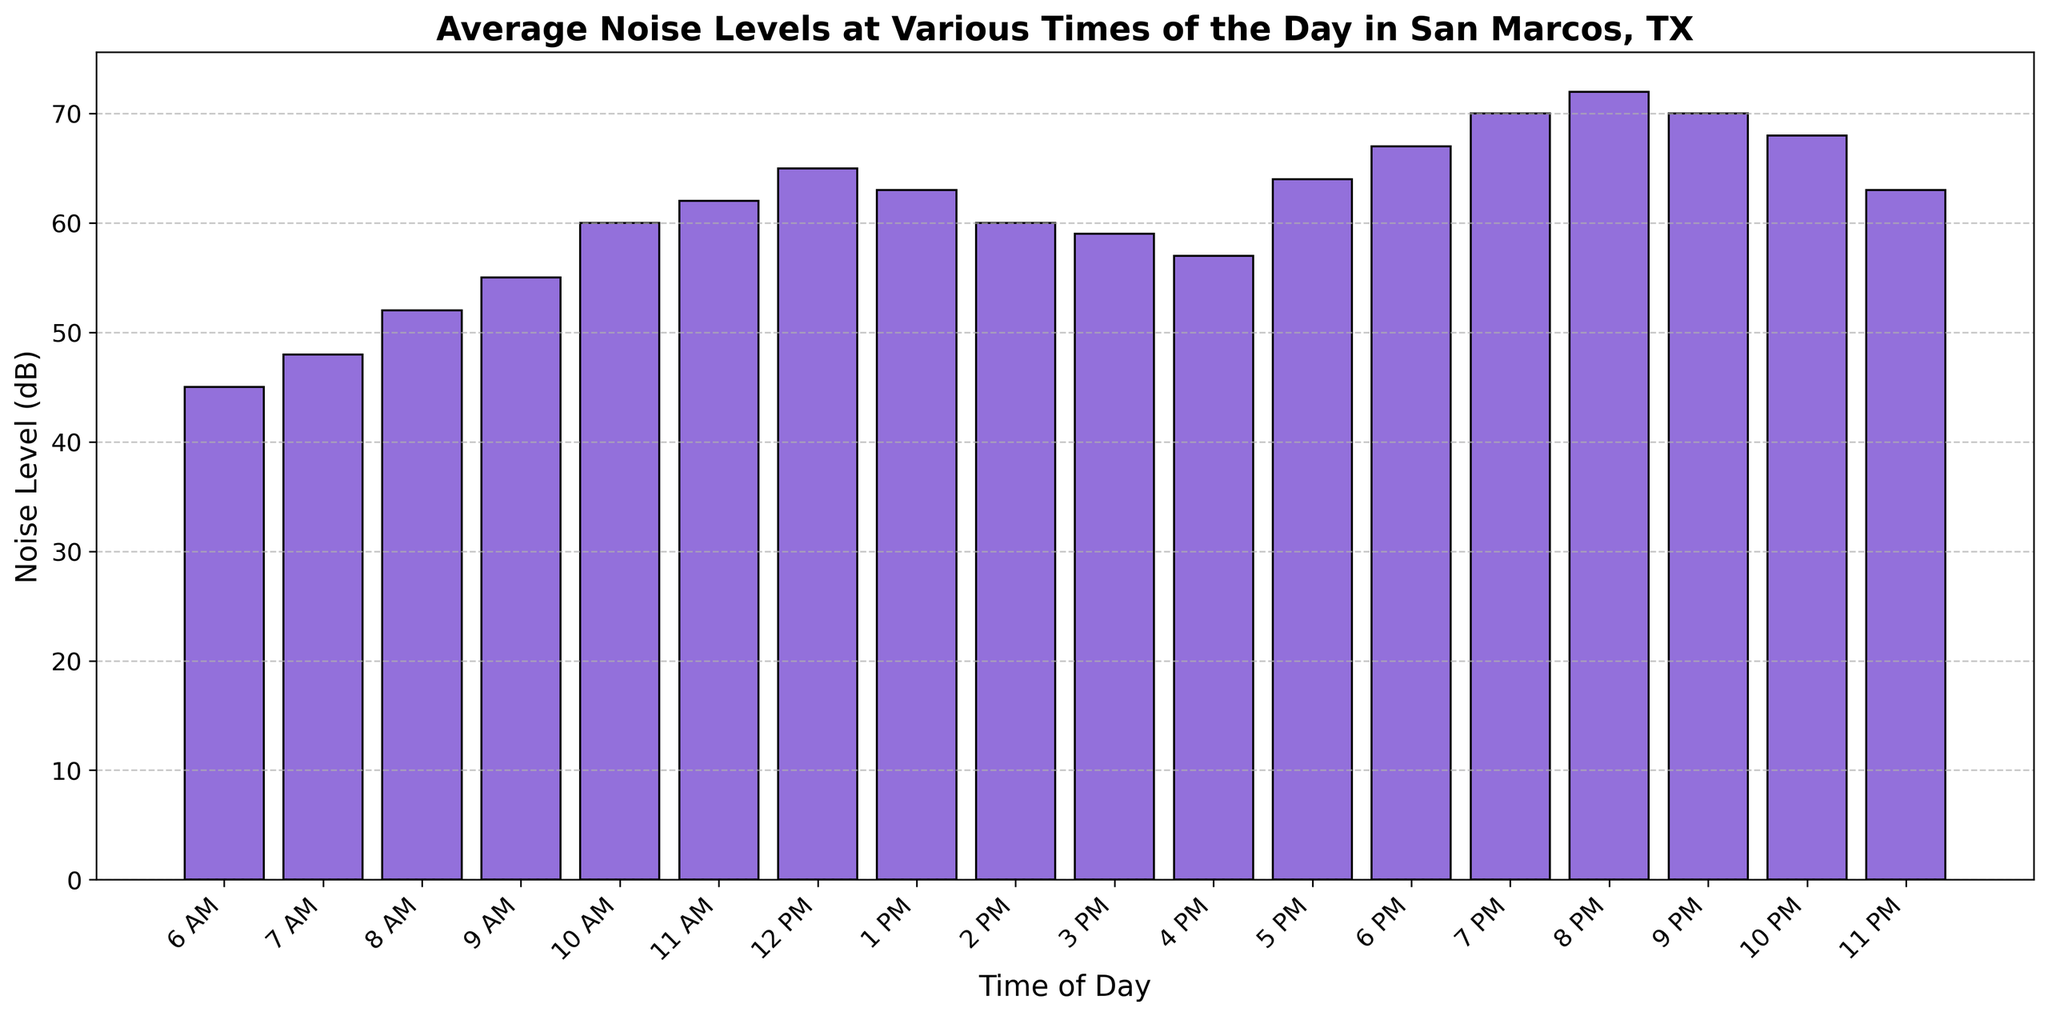What's the peak noise level throughout the day? First, scan the bar heights, noting the tallest bar. The highest bar corresponds to 8 PM with a noise level of 72 dB.
Answer: 72 dB During which time slots is the noise level equal to 70 dB? Check the heights of the bars and find those equal to the level at which 70 dB is marked. The bars at 7 PM and 9 PM represent 70 dB.
Answer: 7 PM, 9 PM When does the noise level first exceed 60 dB? Find the first instance where the bar height surpasses the 60 dB line on the y-axis. This occurs at 10 AM.
Answer: 10 AM What is the difference in noise level between 8 AM and 5 PM? Locate the bars for 8 AM (52 dB) and 5 PM (64 dB), then subtract the lower value from the higher value: 64 dB - 52 dB = 12 dB.
Answer: 12 dB What times have noise levels below 50 dB? Identify bars lower than the 50 dB mark. These correspond to 6 AM and 7 AM.
Answer: 6 AM, 7 AM Is the noise level at 6 PM greater than at 2 PM? Compare the heights of the bars labeled 6 PM (67 dB) and 2 PM (60 dB); 67 dB is greater than 60 dB.
Answer: Yes What’s the average noise level between 10 PM and 11 PM? Find noise levels for 10 PM (68 dB) and 11 PM (63 dB), sum them (68 + 63 = 131), then divide by 2. The average is 131 / 2 = 65.5 dB.
Answer: 65.5 dB At what time(s) is the noise level exactly 63 dB? Check bar heights to see which correspond exactly to 63 dB. These occur at 1 PM and 11 PM.
Answer: 1 PM, 11 PM What is the difference in noise level between the quietest and loudest times of the day? Identify the quietest time (6 AM, 45 dB) and the loudest time (8 PM, 72 dB), then compute the difference: 72 dB - 45 dB = 27 dB.
Answer: 27 dB Between which consecutive hours does the noise level increase the most? Find differences between each consecutive pair of bars; the largest increase is from 10 PM (68 dB) to 11 PM (63 dB), with a jump of -5 dB. However, for increases, look from 11 AM (62 dB) to 12 PM (65 dB), which is 3 dB.
Answer: 11 AM to 12 PM 